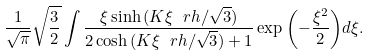Convert formula to latex. <formula><loc_0><loc_0><loc_500><loc_500>\frac { 1 } { \sqrt { \pi } } \sqrt { \frac { 3 } { 2 } } \int \frac { \xi \sinh { ( K \xi \ r h / \sqrt { 3 } ) } } { 2 \cosh { ( K \xi \ r h / \sqrt { 3 } ) } + 1 } \exp { \left ( - \frac { \xi ^ { 2 } } { 2 } \right ) } d \xi .</formula> 